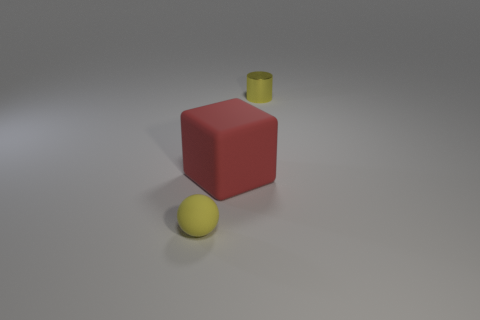Is there any other thing that is the same size as the red object?
Offer a terse response. No. How many other balls are the same size as the sphere?
Your answer should be very brief. 0. What is the small yellow sphere made of?
Your answer should be compact. Rubber. Is the number of red rubber cubes greater than the number of large green shiny spheres?
Ensure brevity in your answer.  Yes. Does the red object have the same shape as the small yellow matte object?
Offer a terse response. No. Are there any other things that have the same shape as the tiny yellow metallic object?
Offer a very short reply. No. Do the small object in front of the big red matte thing and the rubber thing that is behind the tiny ball have the same color?
Your response must be concise. No. Are there fewer small metal things behind the cube than red matte things behind the shiny cylinder?
Ensure brevity in your answer.  No. There is a small object on the right side of the yellow sphere; what shape is it?
Ensure brevity in your answer.  Cylinder. There is a tiny thing that is the same color as the small rubber ball; what is its material?
Your response must be concise. Metal. 